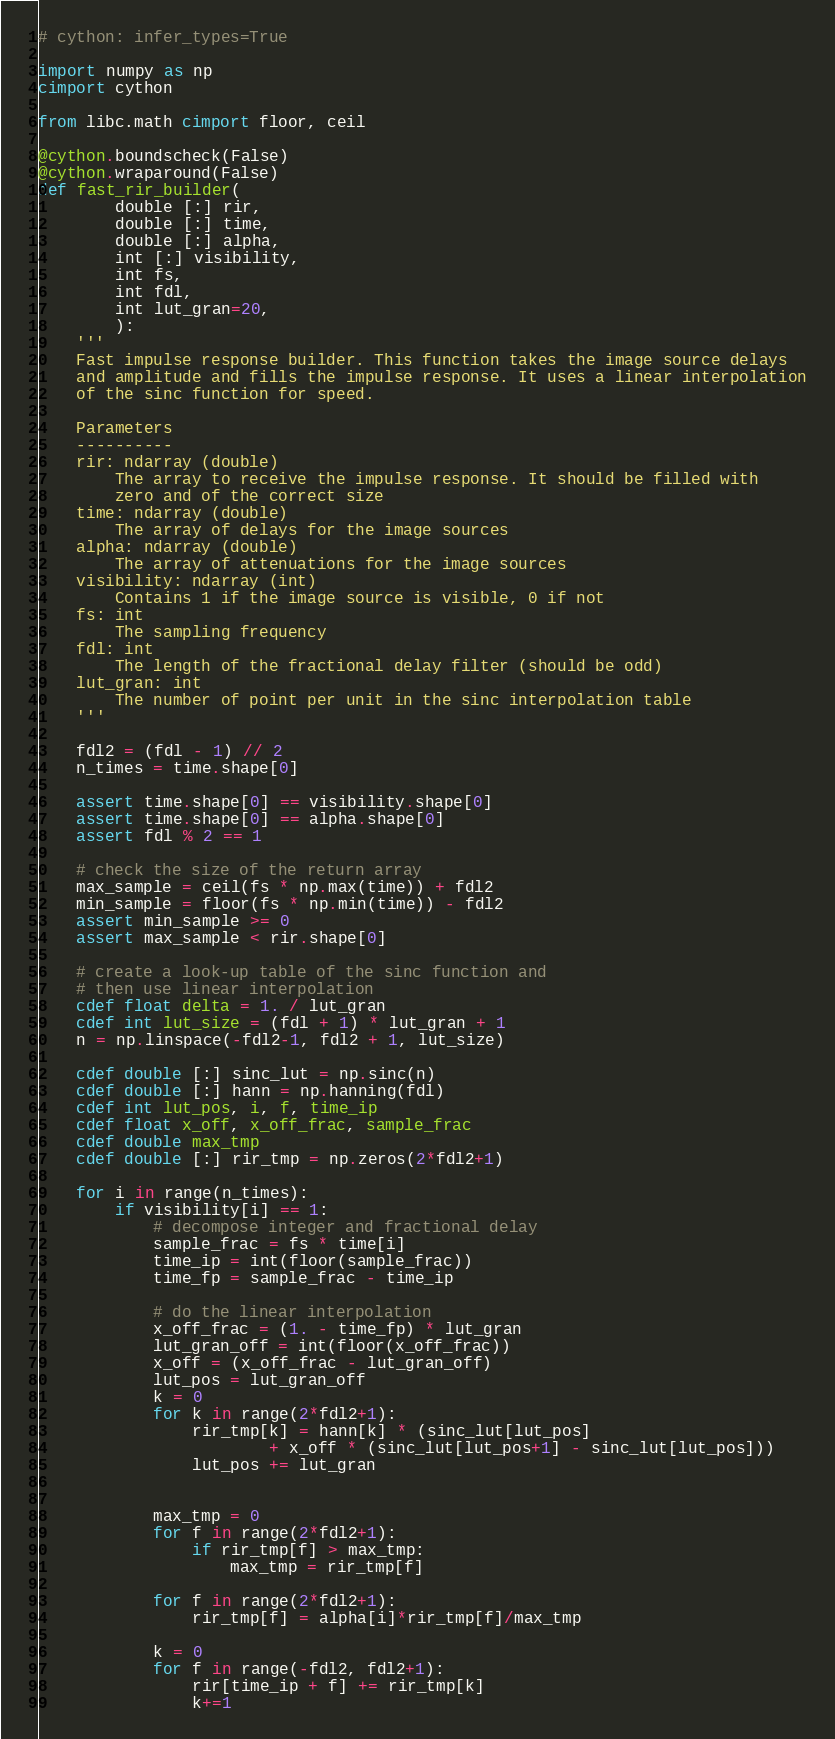Convert code to text. <code><loc_0><loc_0><loc_500><loc_500><_Cython_># cython: infer_types=True

import numpy as np
cimport cython

from libc.math cimport floor, ceil

@cython.boundscheck(False)
@cython.wraparound(False)
def fast_rir_builder(
        double [:] rir,
        double [:] time,
        double [:] alpha,
        int [:] visibility,
        int fs,
        int fdl,
        int lut_gran=20,
        ):
    '''
    Fast impulse response builder. This function takes the image source delays
    and amplitude and fills the impulse response. It uses a linear interpolation
    of the sinc function for speed.

    Parameters
    ----------
    rir: ndarray (double)
        The array to receive the impulse response. It should be filled with
        zero and of the correct size
    time: ndarray (double)
        The array of delays for the image sources
    alpha: ndarray (double)
        The array of attenuations for the image sources
    visibility: ndarray (int)
        Contains 1 if the image source is visible, 0 if not
    fs: int
        The sampling frequency
    fdl: int
        The length of the fractional delay filter (should be odd)
    lut_gran: int
        The number of point per unit in the sinc interpolation table
    '''

    fdl2 = (fdl - 1) // 2
    n_times = time.shape[0]

    assert time.shape[0] == visibility.shape[0]
    assert time.shape[0] == alpha.shape[0]
    assert fdl % 2 == 1

    # check the size of the return array
    max_sample = ceil(fs * np.max(time)) + fdl2
    min_sample = floor(fs * np.min(time)) - fdl2
    assert min_sample >= 0
    assert max_sample < rir.shape[0]

    # create a look-up table of the sinc function and
    # then use linear interpolation
    cdef float delta = 1. / lut_gran
    cdef int lut_size = (fdl + 1) * lut_gran + 1
    n = np.linspace(-fdl2-1, fdl2 + 1, lut_size)

    cdef double [:] sinc_lut = np.sinc(n)
    cdef double [:] hann = np.hanning(fdl)
    cdef int lut_pos, i, f, time_ip
    cdef float x_off, x_off_frac, sample_frac
    cdef double max_tmp
    cdef double [:] rir_tmp = np.zeros(2*fdl2+1)

    for i in range(n_times):
        if visibility[i] == 1:
            # decompose integer and fractional delay
            sample_frac = fs * time[i]
            time_ip = int(floor(sample_frac))
            time_fp = sample_frac - time_ip

            # do the linear interpolation
            x_off_frac = (1. - time_fp) * lut_gran
            lut_gran_off = int(floor(x_off_frac))
            x_off = (x_off_frac - lut_gran_off)
            lut_pos = lut_gran_off
            k = 0
            for k in range(2*fdl2+1):
                rir_tmp[k] = hann[k] * (sinc_lut[lut_pos]
                        + x_off * (sinc_lut[lut_pos+1] - sinc_lut[lut_pos]))
                lut_pos += lut_gran


            max_tmp = 0
            for f in range(2*fdl2+1):
                if rir_tmp[f] > max_tmp:
                    max_tmp = rir_tmp[f]

            for f in range(2*fdl2+1):
                rir_tmp[f] = alpha[i]*rir_tmp[f]/max_tmp

            k = 0
            for f in range(-fdl2, fdl2+1):
                rir[time_ip + f] += rir_tmp[k]
                k+=1
</code> 